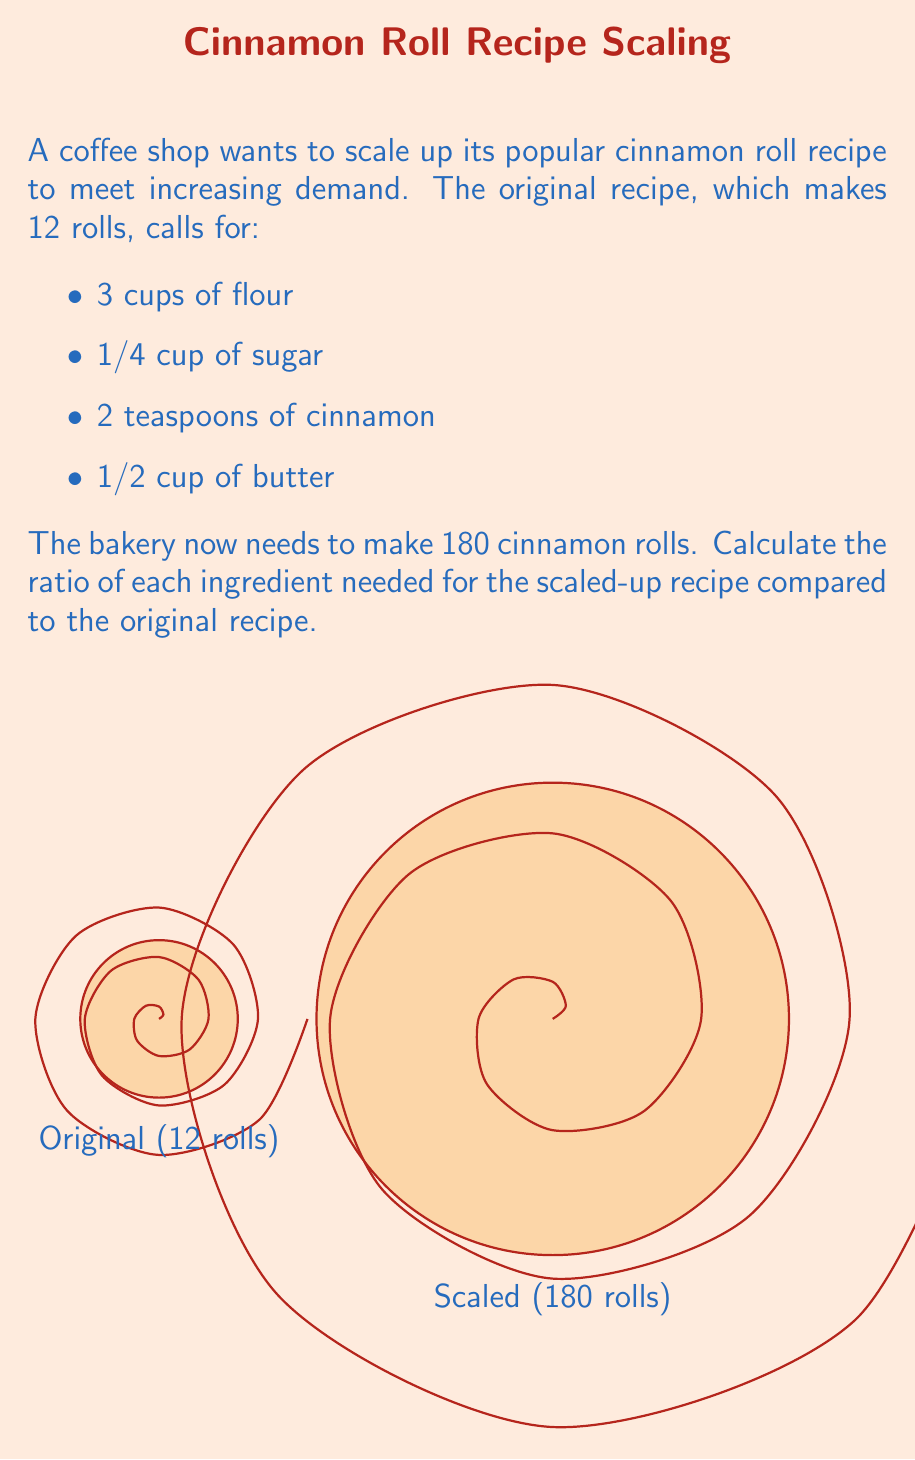Can you answer this question? To solve this problem, we need to determine the scaling factor and then apply it to each ingredient. Let's break it down step-by-step:

1. Calculate the scaling factor:
   $$\text{Scaling factor} = \frac{\text{New quantity}}{\text{Original quantity}} = \frac{180 \text{ rolls}}{12 \text{ rolls}} = 15$$

2. Apply the scaling factor to each ingredient:

   a) Flour:
      $$3 \text{ cups} \times 15 = 45 \text{ cups}$$
      Ratio: $\frac{45}{3} = 15:1$

   b) Sugar:
      $$\frac{1}{4} \text{ cup} \times 15 = 3\frac{3}{4} \text{ cups}$$
      Ratio: $\frac{3.75}{0.25} = 15:1$

   c) Cinnamon:
      $$2 \text{ teaspoons} \times 15 = 30 \text{ teaspoons}$$
      Ratio: $\frac{30}{2} = 15:1$

   d) Butter:
      $$\frac{1}{2} \text{ cup} \times 15 = 7\frac{1}{2} \text{ cups}$$
      Ratio: $\frac{7.5}{0.5} = 15:1$

3. The ratio for each ingredient is the same: 15:1

This means that for every 1 part of an ingredient in the original recipe, you need 15 parts in the scaled-up recipe.
Answer: 15:1 